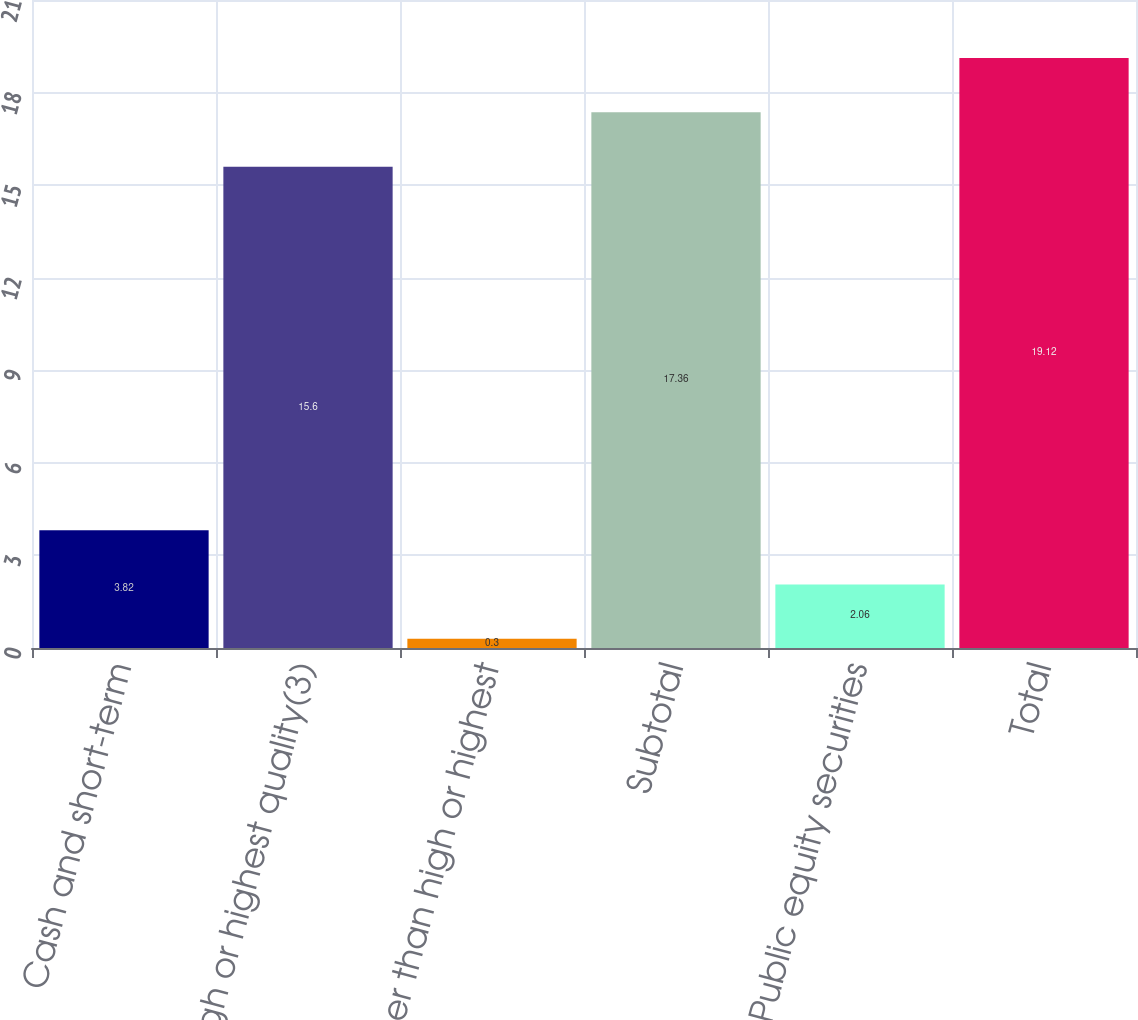<chart> <loc_0><loc_0><loc_500><loc_500><bar_chart><fcel>Cash and short-term<fcel>High or highest quality(3)<fcel>Other than high or highest<fcel>Subtotal<fcel>Public equity securities<fcel>Total<nl><fcel>3.82<fcel>15.6<fcel>0.3<fcel>17.36<fcel>2.06<fcel>19.12<nl></chart> 